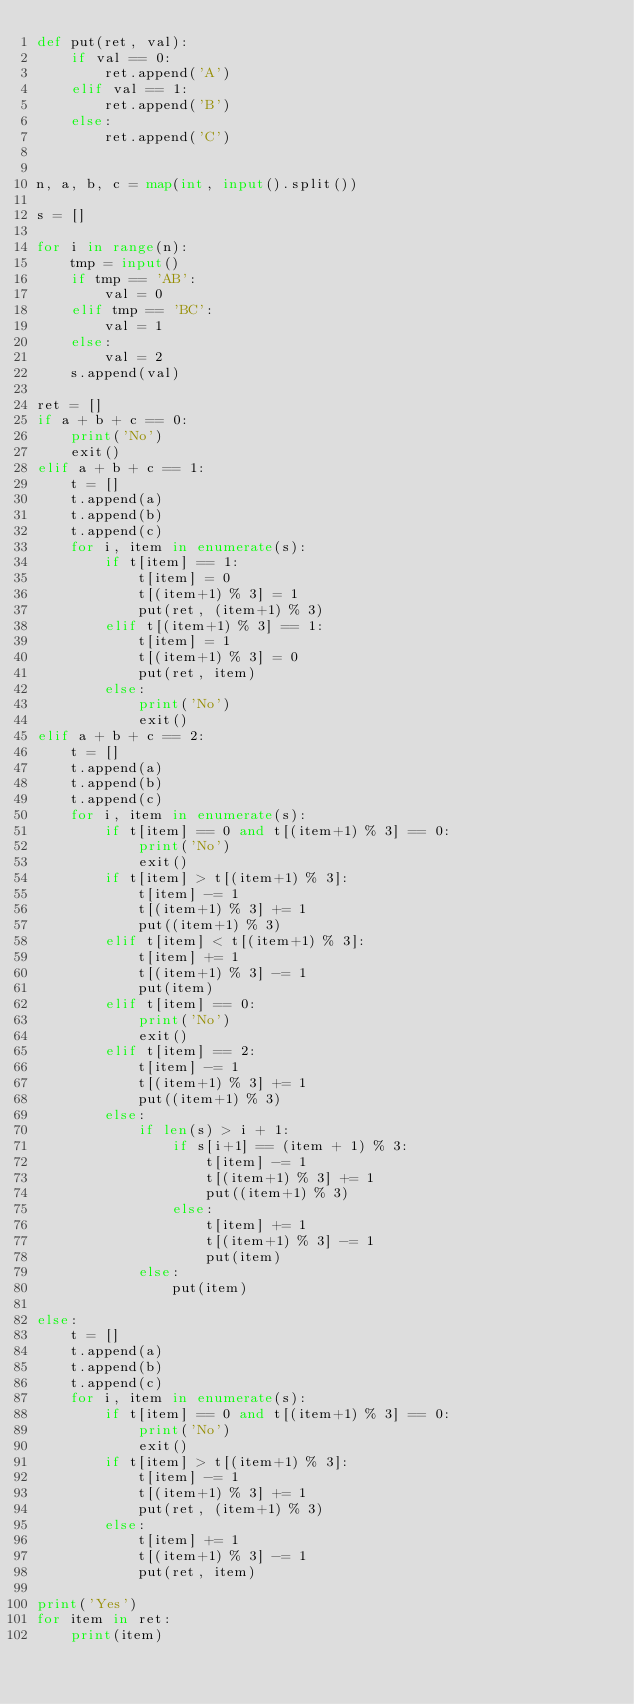<code> <loc_0><loc_0><loc_500><loc_500><_Python_>def put(ret, val):
    if val == 0:
        ret.append('A')
    elif val == 1:
        ret.append('B')
    else:
        ret.append('C')


n, a, b, c = map(int, input().split())

s = []

for i in range(n):
    tmp = input()
    if tmp == 'AB':
        val = 0
    elif tmp == 'BC':
        val = 1
    else:
        val = 2
    s.append(val)

ret = []
if a + b + c == 0:
    print('No')
    exit()
elif a + b + c == 1:
    t = []
    t.append(a)
    t.append(b)
    t.append(c)
    for i, item in enumerate(s):
        if t[item] == 1:
            t[item] = 0
            t[(item+1) % 3] = 1
            put(ret, (item+1) % 3)
        elif t[(item+1) % 3] == 1:
            t[item] = 1
            t[(item+1) % 3] = 0
            put(ret, item)
        else:
            print('No')
            exit()
elif a + b + c == 2:
    t = []
    t.append(a)
    t.append(b)
    t.append(c)
    for i, item in enumerate(s):
        if t[item] == 0 and t[(item+1) % 3] == 0:
            print('No')
            exit()
        if t[item] > t[(item+1) % 3]:
            t[item] -= 1
            t[(item+1) % 3] += 1
            put((item+1) % 3)
        elif t[item] < t[(item+1) % 3]:
            t[item] += 1
            t[(item+1) % 3] -= 1
            put(item)
        elif t[item] == 0:
            print('No')
            exit()
        elif t[item] == 2:
            t[item] -= 1
            t[(item+1) % 3] += 1
            put((item+1) % 3)
        else:
            if len(s) > i + 1:
                if s[i+1] == (item + 1) % 3:
                    t[item] -= 1
                    t[(item+1) % 3] += 1
                    put((item+1) % 3)
                else:
                    t[item] += 1
                    t[(item+1) % 3] -= 1
                    put(item)
            else:
                put(item)

else:
    t = []
    t.append(a)
    t.append(b)
    t.append(c)
    for i, item in enumerate(s):
        if t[item] == 0 and t[(item+1) % 3] == 0:
            print('No')
            exit()
        if t[item] > t[(item+1) % 3]:
            t[item] -= 1
            t[(item+1) % 3] += 1
            put(ret, (item+1) % 3)
        else:
            t[item] += 1
            t[(item+1) % 3] -= 1
            put(ret, item)

print('Yes')
for item in ret:
    print(item)
</code> 